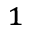Convert formula to latex. <formula><loc_0><loc_0><loc_500><loc_500>_ { 1 }</formula> 